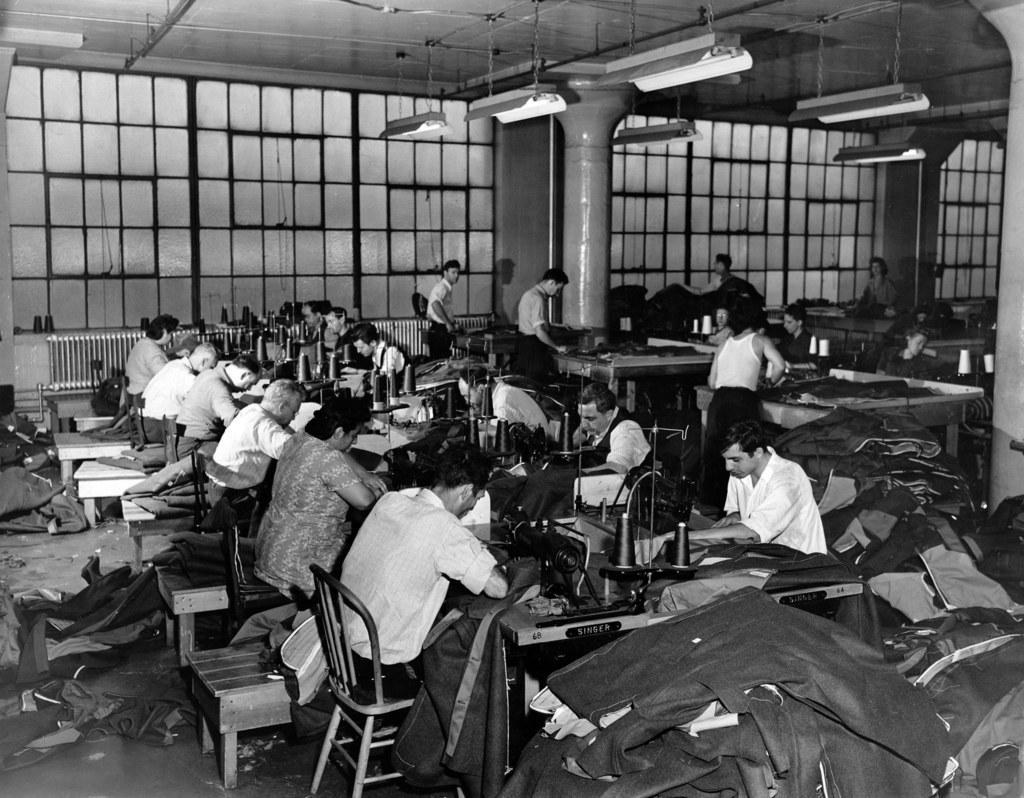Please provide a concise description of this image. In this image I can see group of people sitting on the chairs. In front of them there is a sewing machine. From them some people are stitching the clothes and of them are standing and doing something. I can also see window,lights,roof in the image. 